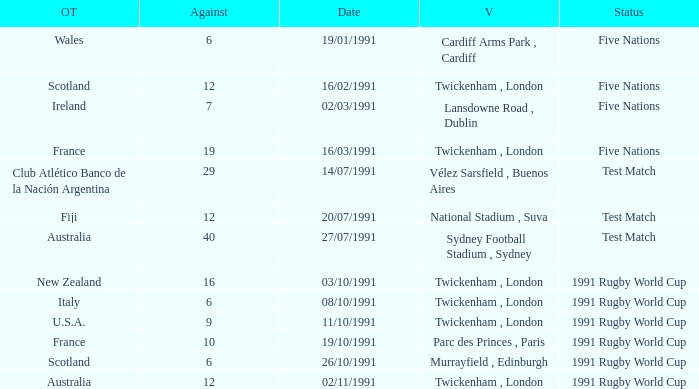What is Venue, when Status is "Test Match", and when Against is "12"? National Stadium , Suva. 